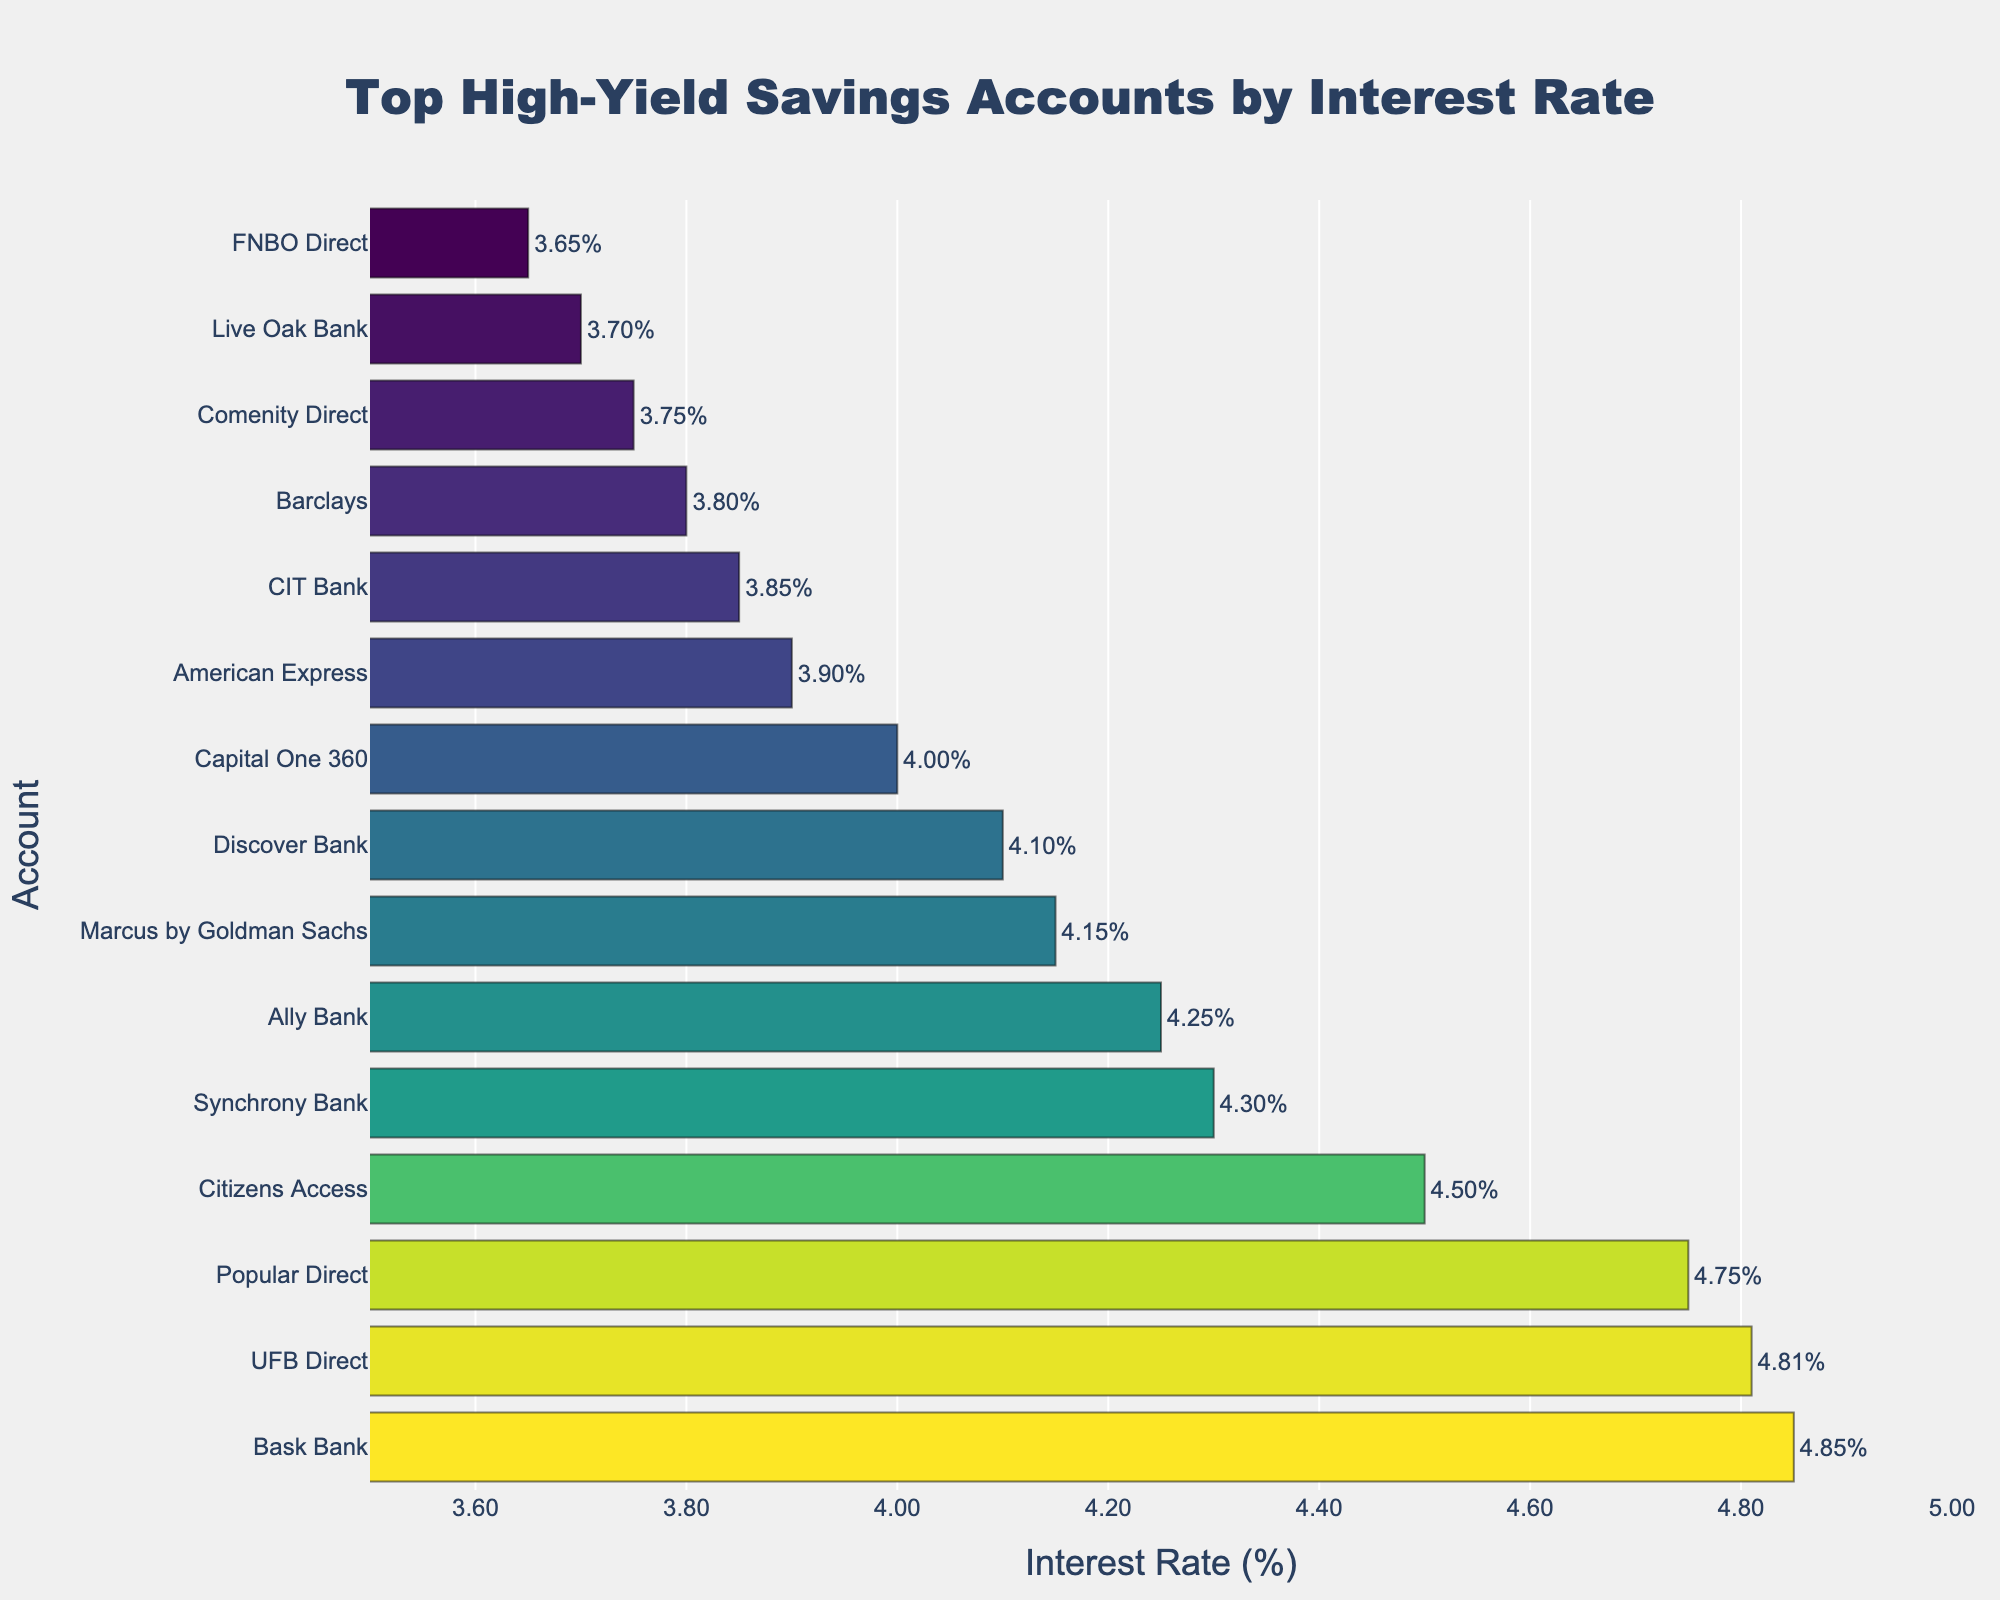Which account offers the highest interest rate? By looking at the bar chart, identify the account associated with the longest bar or the highest position.
Answer: Bask Bank Which accounts have an interest rate greater than 4.75%? Locate and list down all the bars with an interest rate above 4.75% on the x-axis.
Answer: Bask Bank, UFB Direct, Popular Direct How much higher is the interest rate of Bask Bank compared to American Express? Find the interest rates for both Bask Bank and American Express, then subtract the latter from the former: 4.85% - 3.90%.
Answer: 0.95% How many accounts have interest rates between 4.00% and 4.50%? Count the number of bars that fall within the specified range on the x-axis.
Answer: 4 Which account has a shorter bar: Discover Bank or CIT Bank? Compare the lengths of the bars for Discover Bank and CIT Bank by looking at the x-axis values.
Answer: CIT Bank What's the difference in interest rate between the highest and lowest account in the top 10? Identify the highest interest rate in the top 10 (Bask Bank at 4.85%) and the lowest in the top 10 (Capital One 360 at 4.00%), then subtract the latter from the former.
Answer: 0.85% What is the average interest rate of the top 3 accounts? Add the interest rates of the top 3 accounts (Bask Bank, UFB Direct, Popular Direct) and divide by 3: (4.85 + 4.81 + 4.75) / 3.
Answer: 4.80% Is the interest rate of Ally Bank higher or lower than the rate of Marcus by Goldman Sachs? Compare the bar lengths or associated numbers for Ally Bank and Marcus by Goldman Sachs.
Answer: Higher Which account is exactly in the middle of the top 10 in terms of interest rate? List the top 10 accounts and find the one located in the middle rank when sorted by interest rate.
Answer: Marcus by Goldman Sachs How much lower is the interest rate of Barclays compared to Synchrony Bank? Subtract Barclays's interest rate from Synchrony Bank's interest rate: 4.30% - 3.80%.
Answer: 0.50% 